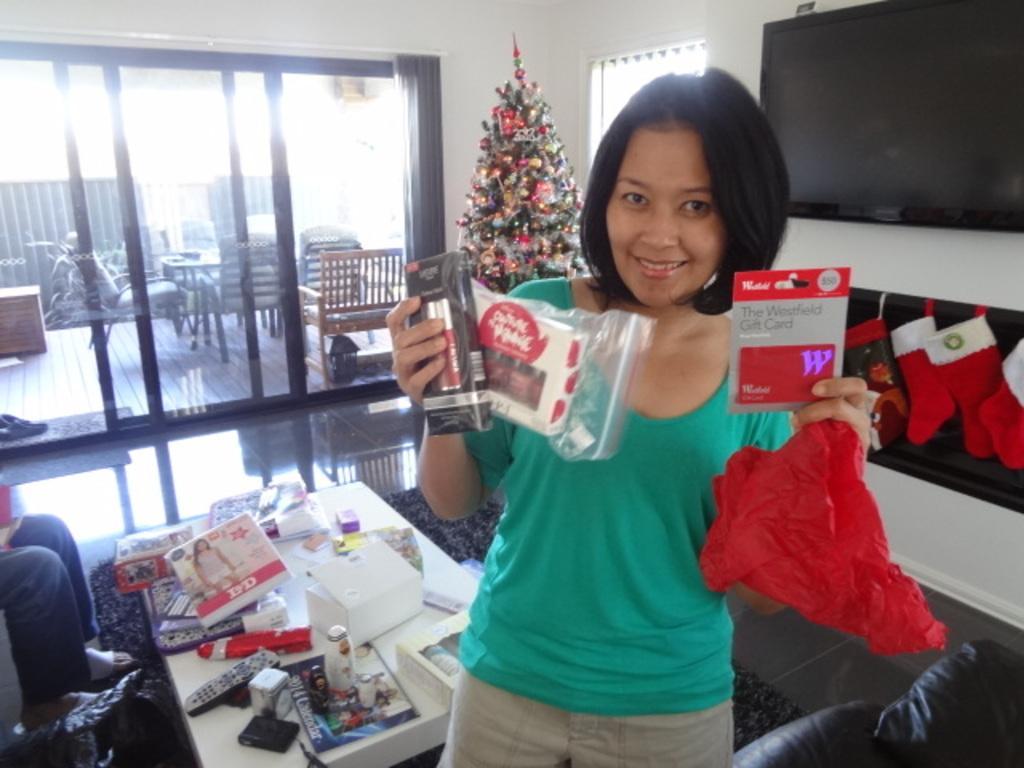Can you describe this image briefly? In this image we can see a woman standing and holding a cover and few objects in her hand, there are person´s legs on the left side and there is a table beside the woman, on the table there is a remote, few boxes and few other objects, on the right side of the image there is a couch, television to the wall and below the television, there are few socks hanged to the wall, there is a mat under the table, in the background there is a Christmas tree, a window and a glass door, through the glass door we can see few chair, a table, few vehicles, wall and a doormat, there are footwear on the mat. 